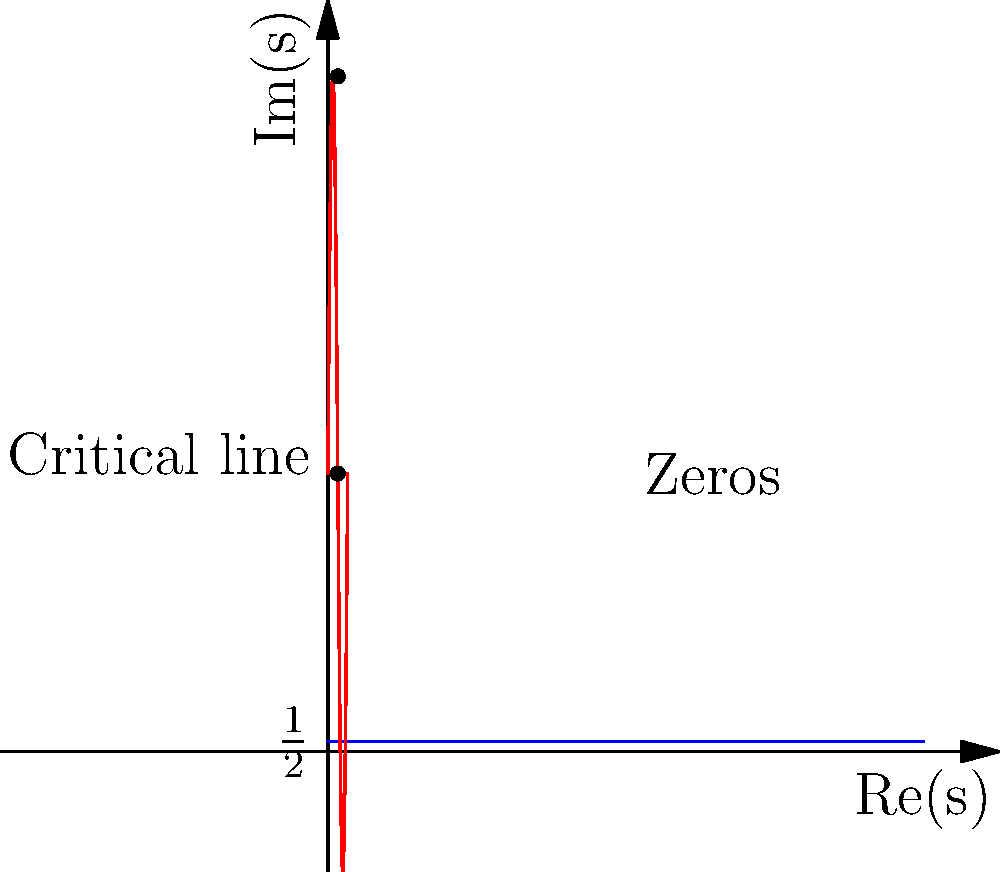In the context of the Riemann zeta function, examine the graph above. What does the blue line represent, and what significant feature of the Riemann Hypothesis is illustrated by the red curve? To answer this question, let's break down the key elements of the graph:

1. The blue line:
   - It's a straight horizontal line at $y = \frac{1}{2}$.
   - In the context of the Riemann zeta function, this represents the critical line $\text{Re}(s) = \frac{1}{2}$.

2. The red curve:
   - It's a sinusoidal curve that oscillates around $y = 14$.
   - In this representation, it illustrates the imaginary parts of the non-trivial zeros of the Riemann zeta function.

3. The Riemann Hypothesis connection:
   - The Riemann Hypothesis states that all non-trivial zeros of the zeta function lie on the critical line $\text{Re}(s) = \frac{1}{2}$.
   - In the graph, we see that the red curve (representing the zeros) intersects the blue line (the critical line) at regular intervals.

4. Significance:
   - This visualization supports the Riemann Hypothesis by showing that the zeros (represented by the intersections of the red curve with the blue line) all occur on the critical line.
   - If the Riemann Hypothesis is true, all these intersections should happen exactly on the blue line, as shown in the graph.

Therefore, the blue line represents the critical line $\text{Re}(s) = \frac{1}{2}$, and the red curve illustrates that the non-trivial zeros of the Riemann zeta function appear to lie on this critical line, which is the central claim of the Riemann Hypothesis.
Answer: The blue line represents the critical line $\text{Re}(s) = \frac{1}{2}$, and the red curve illustrates that the non-trivial zeros of the Riemann zeta function lie on this critical line. 